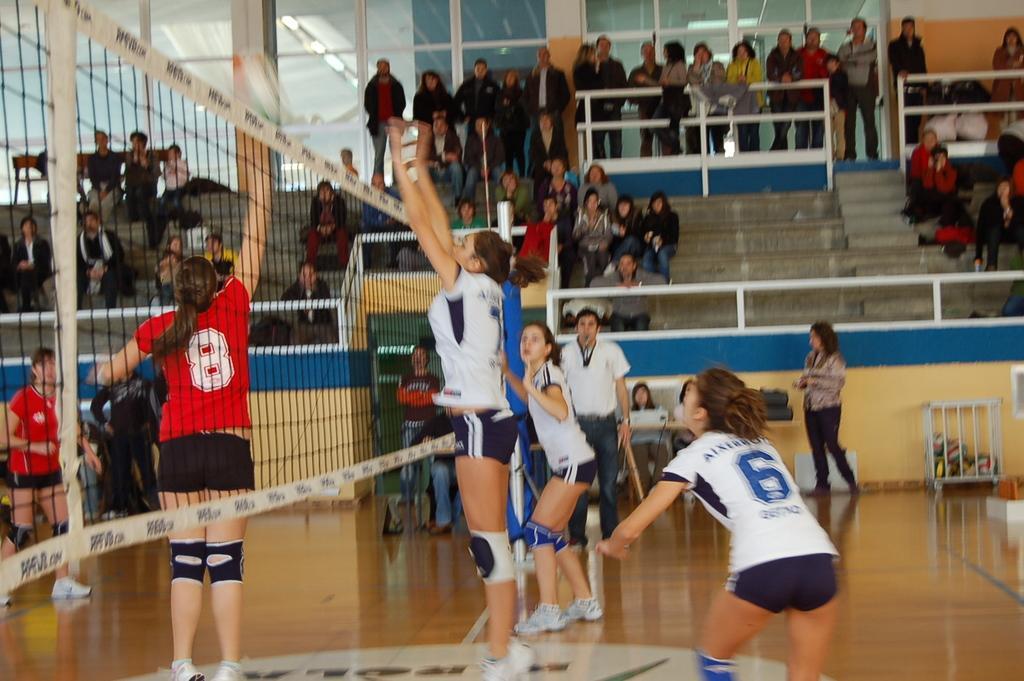In one or two sentences, can you explain what this image depicts? In this picture there are girls in the center of the image, there is net on the left side of the image and there are other people those who are sitting on stairs in the background area of the image and there are glass windows at the top side of the image. 